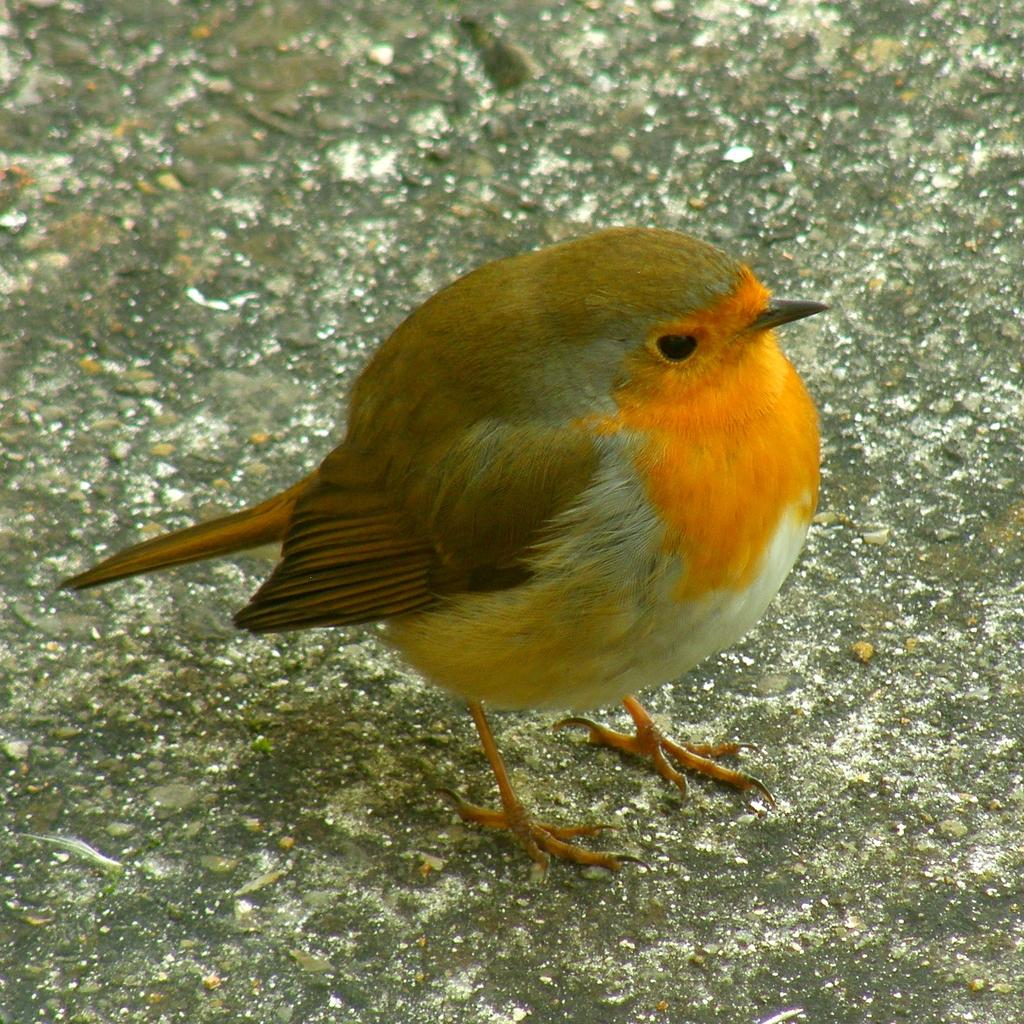What type of animal is present in the image? There is a bird in the image. What colors can be seen on the bird? The bird is ash, orange, and white in color. Where is the bird located in the image? The bird is standing on the floor. Can you tell me how many fish are swimming under the umbrella in the image? There is no umbrella or fish present in the image; it features a bird standing on the floor. 